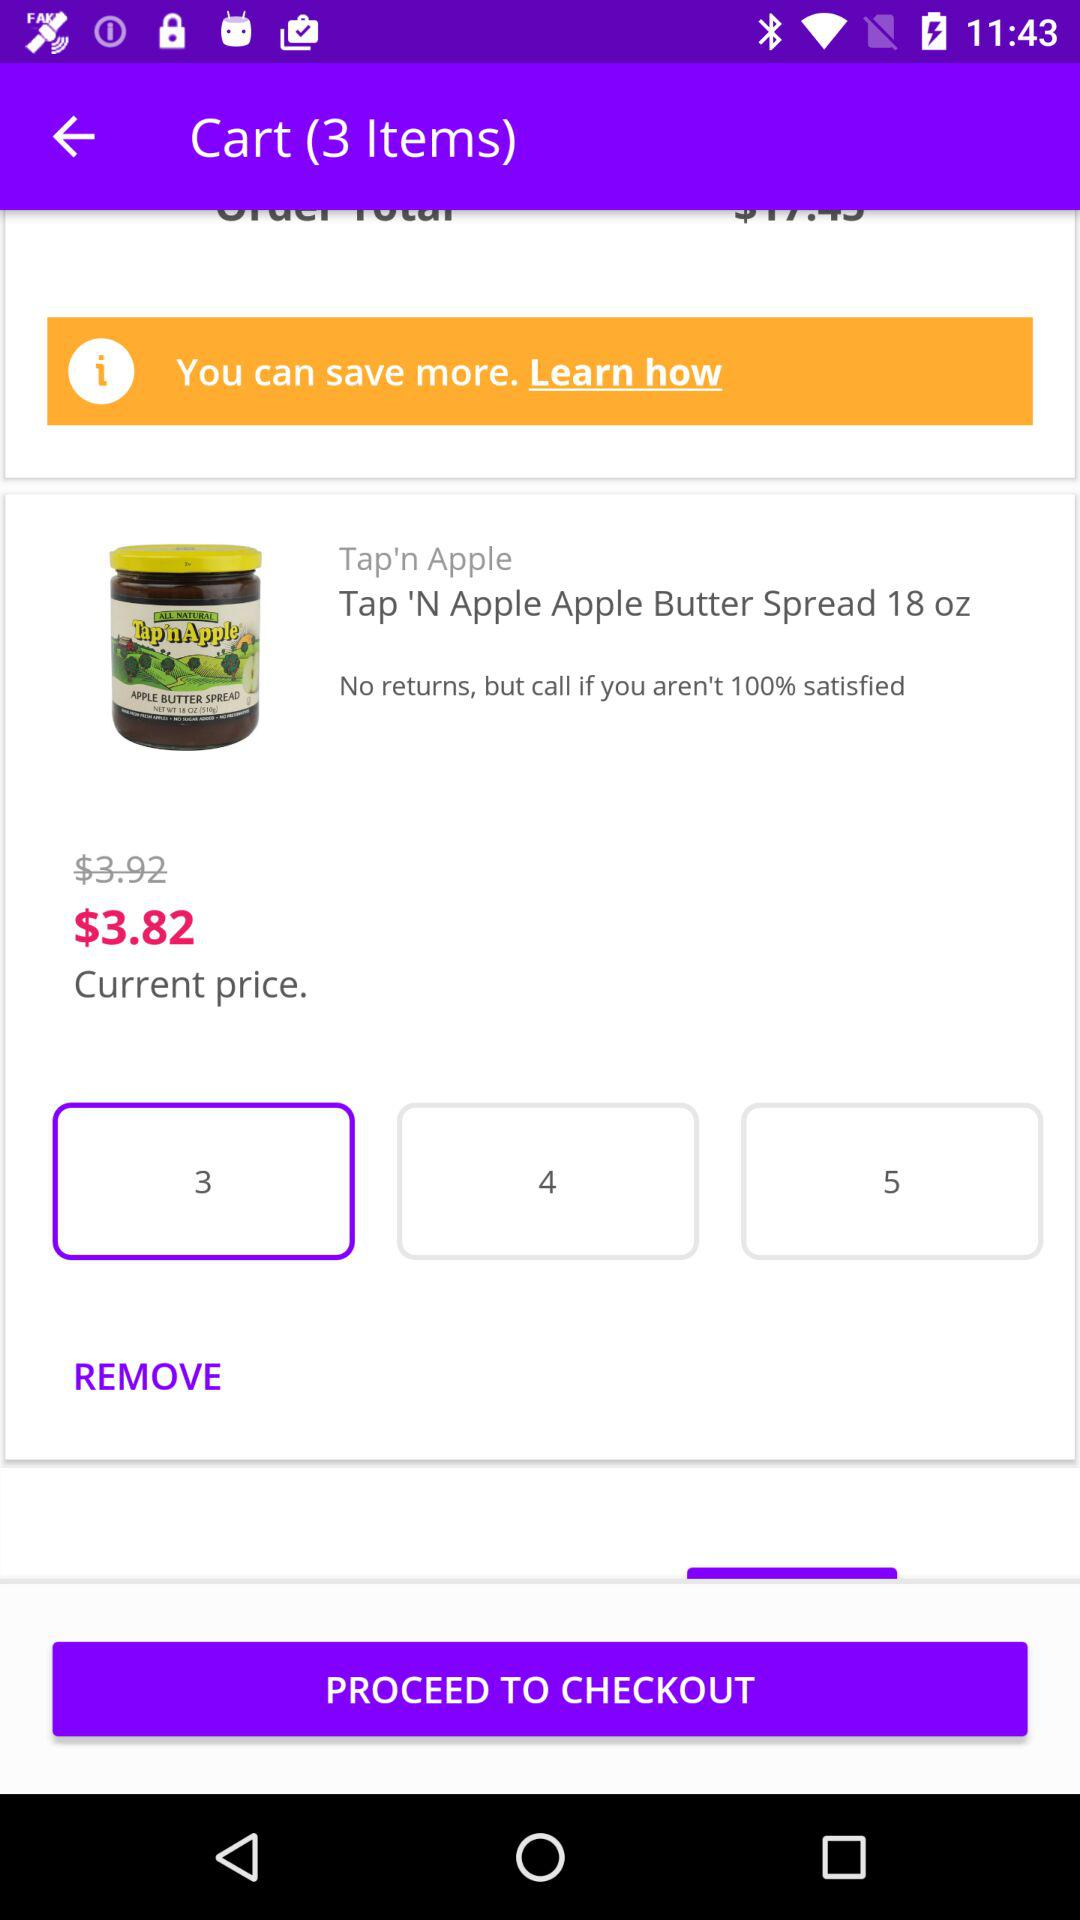How many items are selected? There are 3 items selected. 